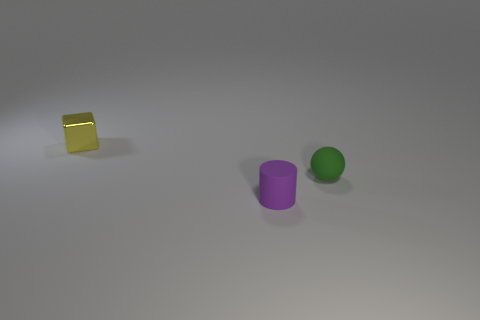How many other objects are there of the same size as the green matte object?
Ensure brevity in your answer.  2. What color is the thing that is to the left of the thing in front of the tiny rubber thing that is behind the small cylinder?
Provide a short and direct response. Yellow. There is a object that is on the right side of the rubber object on the left side of the small green ball; how many small purple things are in front of it?
Your response must be concise. 1. There is a object on the left side of the cylinder; does it have the same size as the green object?
Your answer should be very brief. Yes. There is a small object in front of the ball; how many rubber cylinders are behind it?
Your answer should be compact. 0. There is a tiny thing to the right of the small matte thing that is in front of the green thing; is there a small purple matte cylinder behind it?
Your answer should be compact. No. Are there any other things that are made of the same material as the small yellow object?
Your response must be concise. No. Is the material of the purple thing the same as the tiny green object that is behind the tiny purple matte thing?
Give a very brief answer. Yes. What is the shape of the matte thing behind the tiny thing in front of the tiny ball?
Ensure brevity in your answer.  Sphere. What number of small things are yellow rubber blocks or yellow metallic blocks?
Make the answer very short. 1. 